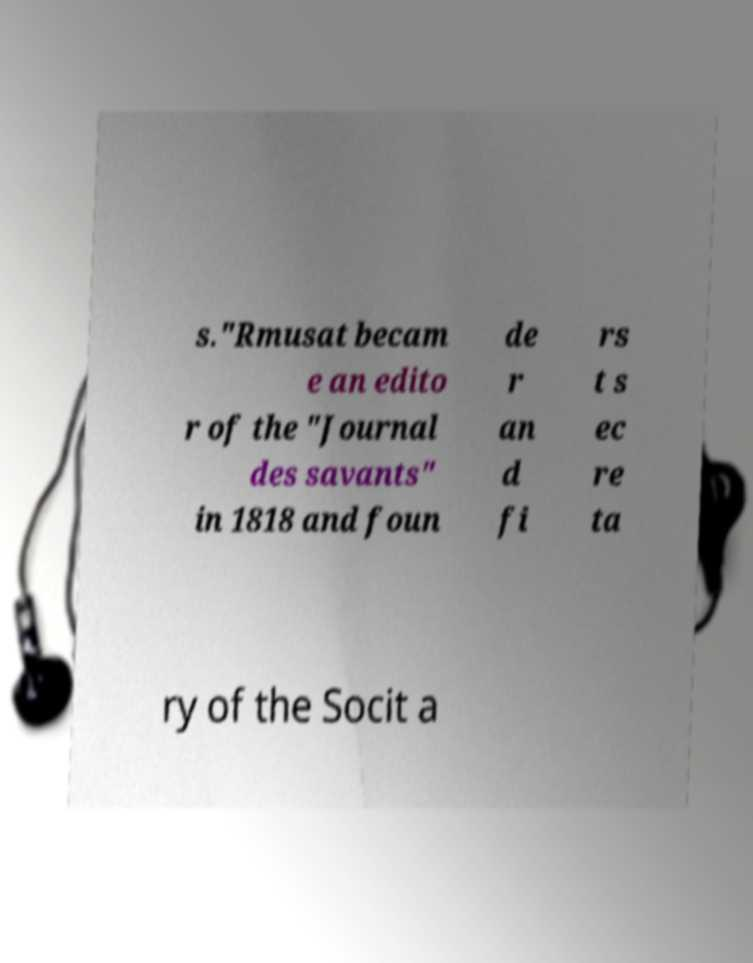Can you read and provide the text displayed in the image?This photo seems to have some interesting text. Can you extract and type it out for me? s."Rmusat becam e an edito r of the "Journal des savants" in 1818 and foun de r an d fi rs t s ec re ta ry of the Socit a 